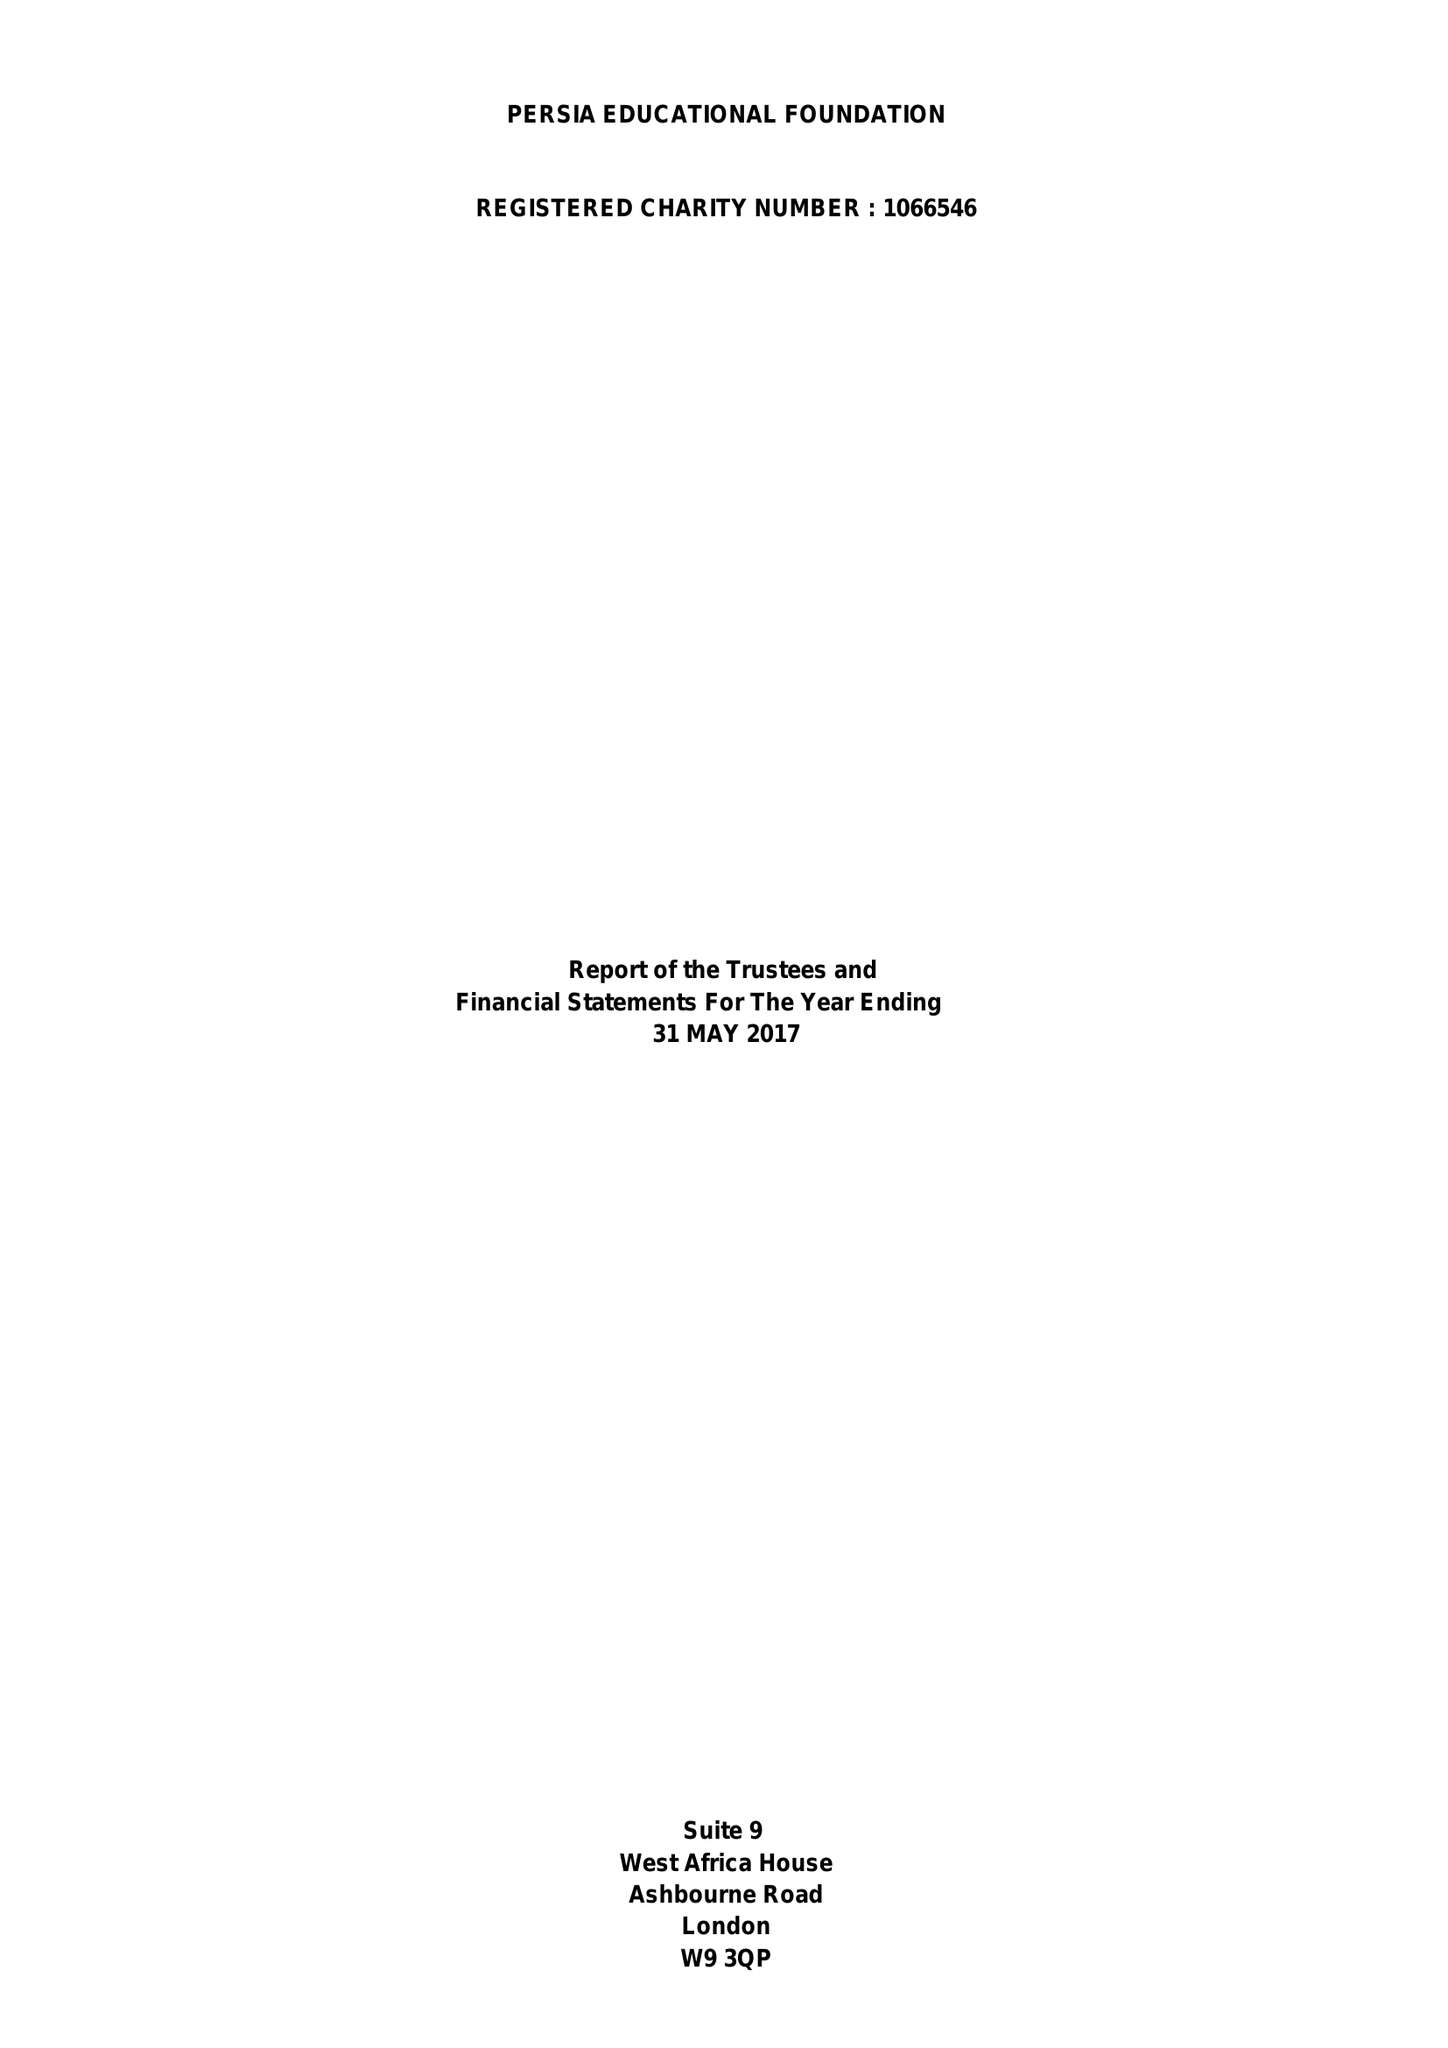What is the value for the charity_number?
Answer the question using a single word or phrase. 1066546 